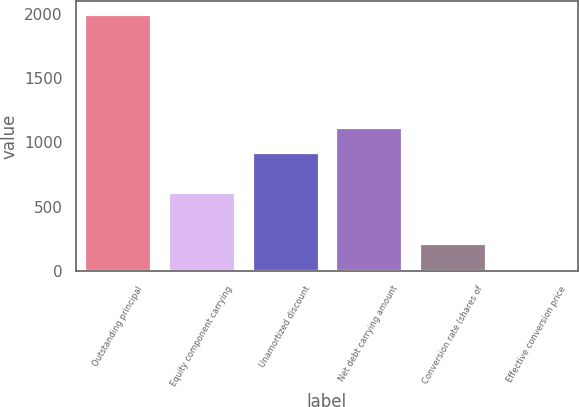Convert chart to OTSL. <chart><loc_0><loc_0><loc_500><loc_500><bar_chart><fcel>Outstanding principal<fcel>Equity component carrying<fcel>Unamortized discount<fcel>Net debt carrying amount<fcel>Conversion rate (shares of<fcel>Effective conversion price<nl><fcel>2000<fcel>613<fcel>922<fcel>1119.78<fcel>219.98<fcel>22.2<nl></chart> 